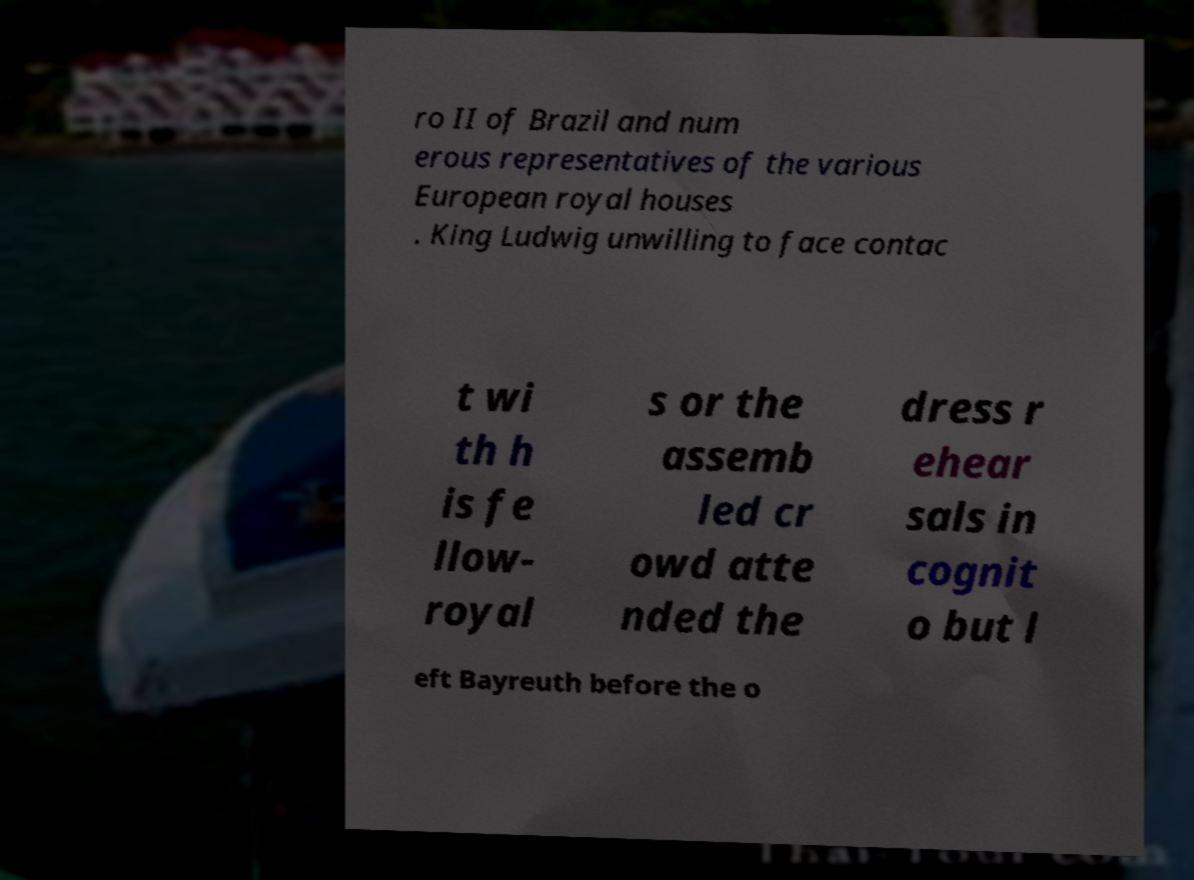I need the written content from this picture converted into text. Can you do that? ro II of Brazil and num erous representatives of the various European royal houses . King Ludwig unwilling to face contac t wi th h is fe llow- royal s or the assemb led cr owd atte nded the dress r ehear sals in cognit o but l eft Bayreuth before the o 